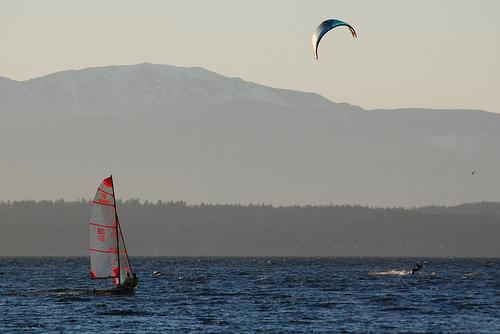Explain what's happening with the boat and the person parasailing. A sailboat with a white and orange sail is on the water, while a person is parasailing above the ocean using a colorful parachute, creating small waves and a wake on the surface. What are some notable features about the sky in the image? There are several white clouds scattered across the blue sky, and a kite soaring high in the atmosphere. List three details about the environment where the boat and person parasailing are present. There's a cool blue sea with small waves, a set of trees behind the water, and distant mountains in the background. Provide an answer that one could use for a multi-choice VQA task, as if a question was asked about the kite. The kite is flying high in the clear blue sky, mainly surrounded by scattered white clouds. Examine the setting where the sailboat is located and analyze the overall mood of the image. The sailboat is set in a serene and peaceful environment with a cool blue sea, trees in the background, and mountains in the distance, giving a sense of tranquility and adventure. For the visual entailment task, describe a scene that would contradict this image. A crowded beach filled with families and children playing in the sand, with no sailboats or parasailing happening in the ocean. Create a short ad for a sailboat company based on the image. Experience freedom on the open water with our sleek and easy-to-handle sailboats. Featuring vibrant orange sails, our boats promise a delightful journey amidst cool sea waves and breathtaking scenery. Sail with us today! 